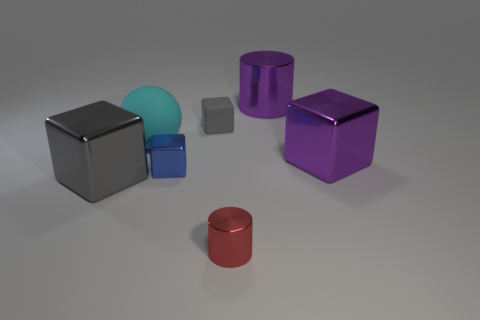How many tiny objects are either spheres or purple matte blocks?
Offer a terse response. 0. What color is the tiny block that is the same material as the big sphere?
Ensure brevity in your answer.  Gray. What number of purple cubes are made of the same material as the big purple cylinder?
Your answer should be compact. 1. There is a cube that is on the left side of the cyan matte ball; is it the same size as the metal cylinder behind the tiny red object?
Your response must be concise. Yes. What is the material of the large block behind the big shiny object in front of the big purple block?
Offer a very short reply. Metal. Are there fewer large cyan rubber things that are behind the tiny gray rubber thing than blue objects that are to the left of the big purple cylinder?
Offer a very short reply. Yes. What is the material of the cube that is the same color as the small rubber thing?
Your answer should be compact. Metal. Is there any other thing that has the same shape as the red metallic object?
Offer a terse response. Yes. There is a big cube that is right of the tiny red shiny thing; what material is it?
Your response must be concise. Metal. Is there anything else that is the same size as the cyan rubber ball?
Your answer should be compact. Yes. 